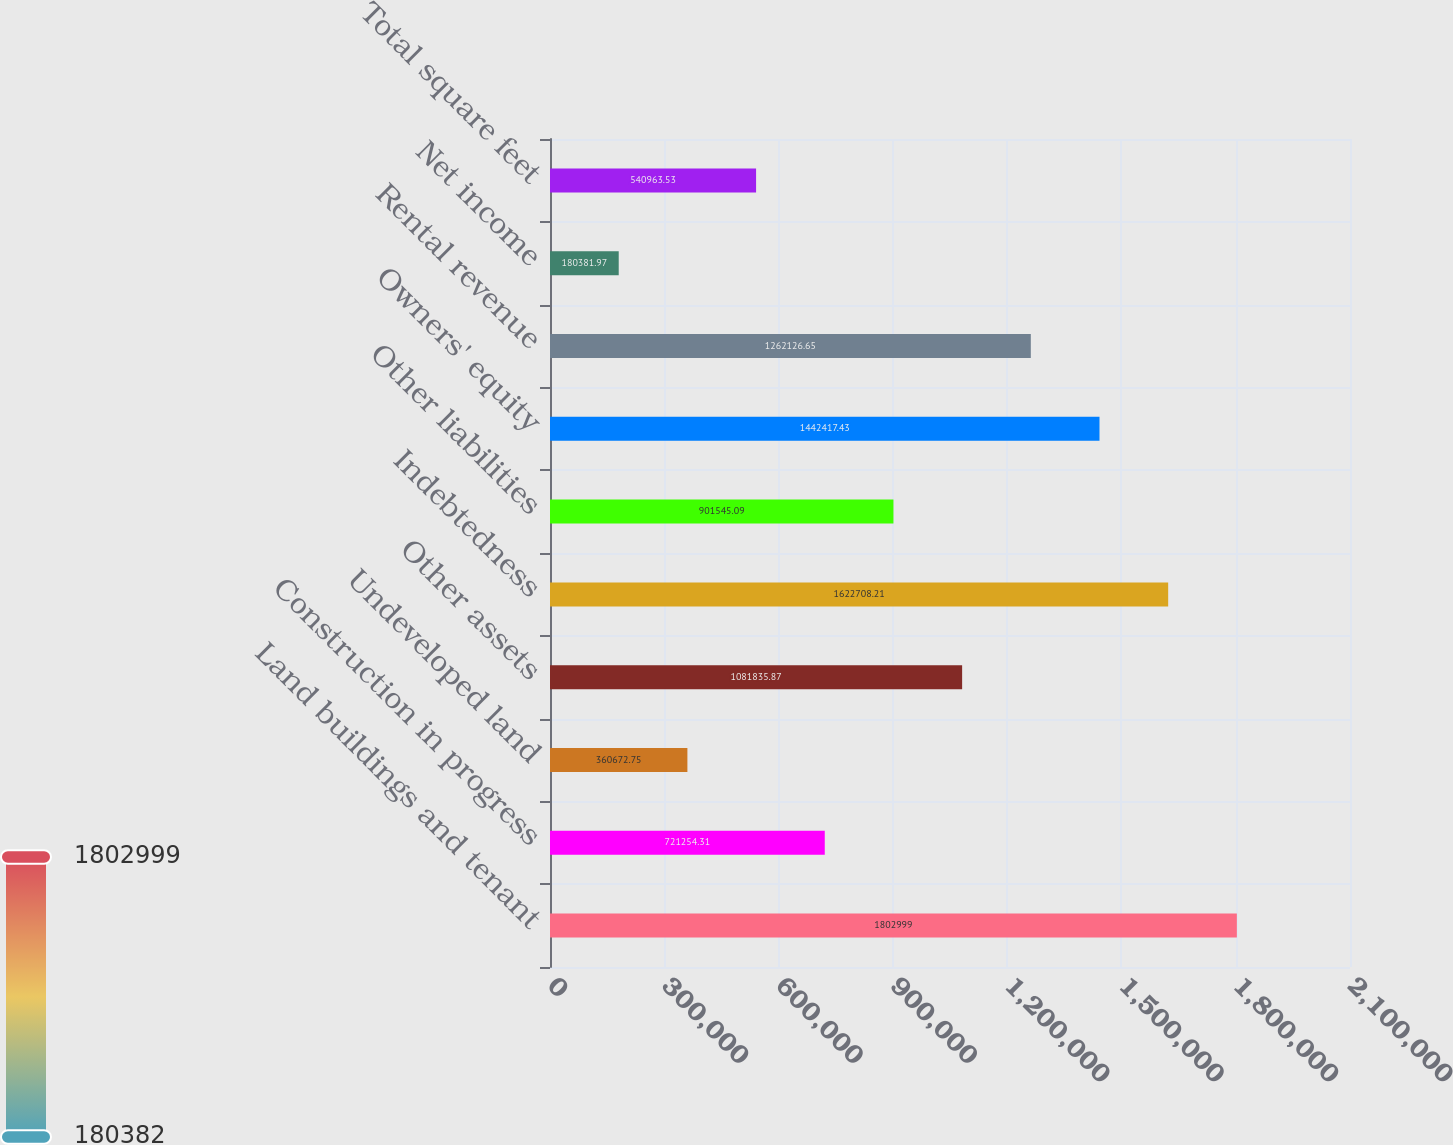<chart> <loc_0><loc_0><loc_500><loc_500><bar_chart><fcel>Land buildings and tenant<fcel>Construction in progress<fcel>Undeveloped land<fcel>Other assets<fcel>Indebtedness<fcel>Other liabilities<fcel>Owners' equity<fcel>Rental revenue<fcel>Net income<fcel>Total square feet<nl><fcel>1.803e+06<fcel>721254<fcel>360673<fcel>1.08184e+06<fcel>1.62271e+06<fcel>901545<fcel>1.44242e+06<fcel>1.26213e+06<fcel>180382<fcel>540964<nl></chart> 